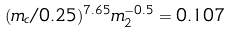<formula> <loc_0><loc_0><loc_500><loc_500>( m _ { c } / 0 . 2 5 ) ^ { 7 . 6 5 } m _ { 2 } ^ { - 0 . 5 } = 0 . 1 0 7</formula> 